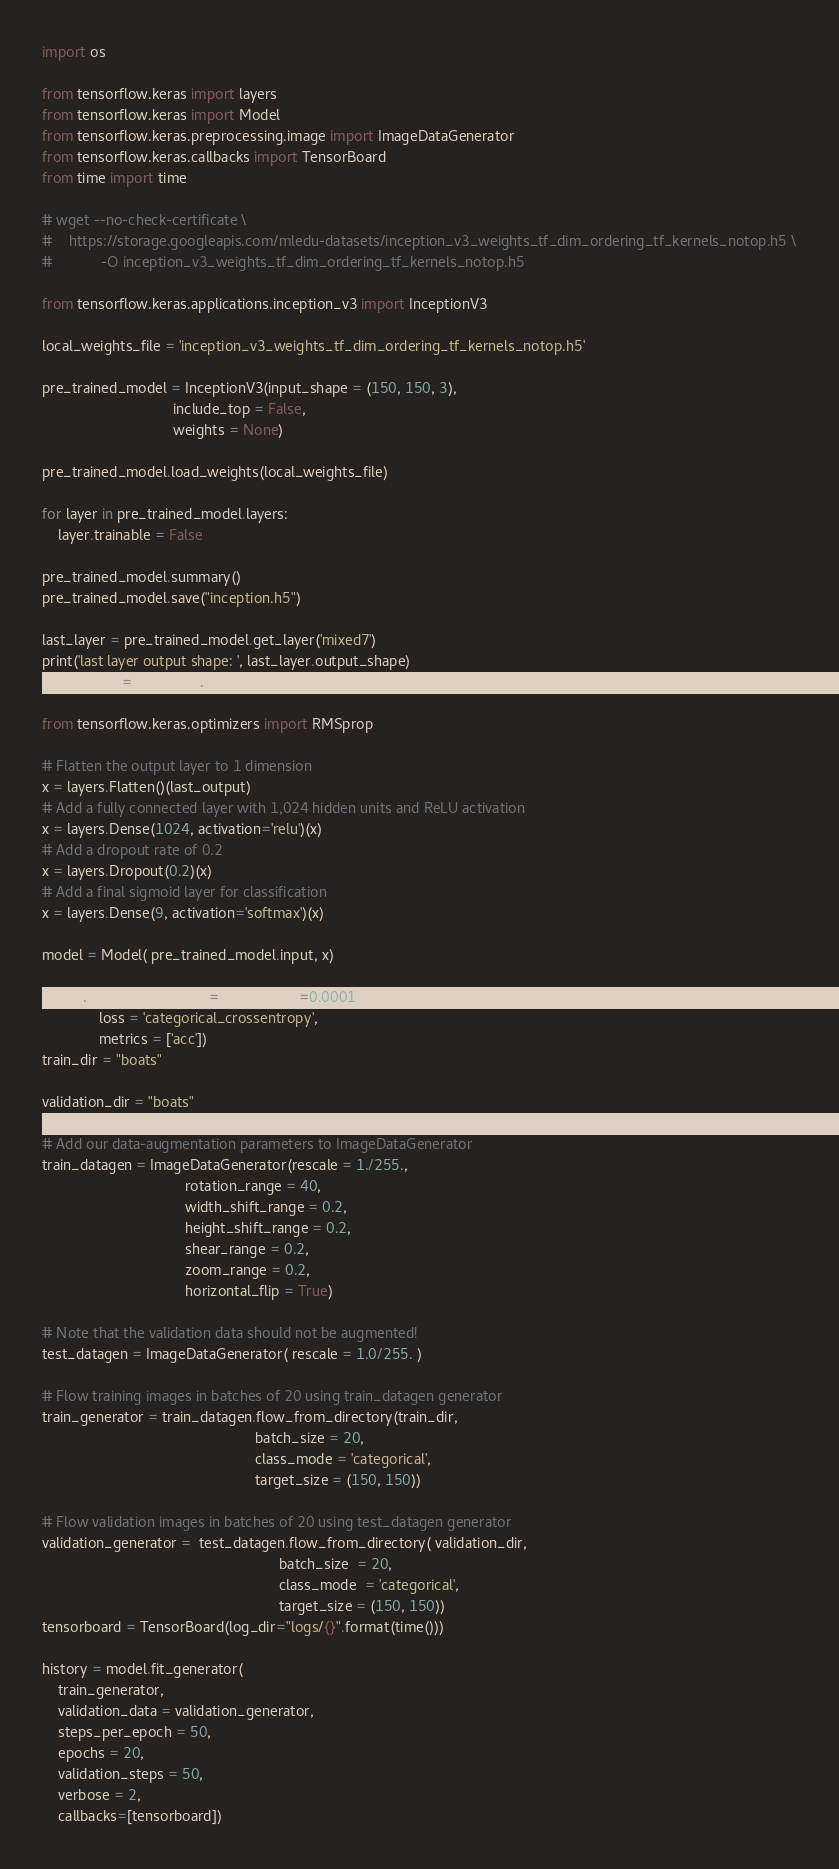Convert code to text. <code><loc_0><loc_0><loc_500><loc_500><_Python_>import os

from tensorflow.keras import layers
from tensorflow.keras import Model
from tensorflow.keras.preprocessing.image import ImageDataGenerator
from tensorflow.keras.callbacks import TensorBoard
from time import time

# wget --no-check-certificate \
#    https://storage.googleapis.com/mledu-datasets/inception_v3_weights_tf_dim_ordering_tf_kernels_notop.h5 \
#            -O inception_v3_weights_tf_dim_ordering_tf_kernels_notop.h5

from tensorflow.keras.applications.inception_v3 import InceptionV3

local_weights_file = 'inception_v3_weights_tf_dim_ordering_tf_kernels_notop.h5'

pre_trained_model = InceptionV3(input_shape = (150, 150, 3),
                                include_top = False,
                                weights = None)

pre_trained_model.load_weights(local_weights_file)

for layer in pre_trained_model.layers:
    layer.trainable = False

pre_trained_model.summary()
pre_trained_model.save("inception.h5")

last_layer = pre_trained_model.get_layer('mixed7')
print('last layer output shape: ', last_layer.output_shape)
last_output = last_layer.output

from tensorflow.keras.optimizers import RMSprop

# Flatten the output layer to 1 dimension
x = layers.Flatten()(last_output)
# Add a fully connected layer with 1,024 hidden units and ReLU activation
x = layers.Dense(1024, activation='relu')(x)
# Add a dropout rate of 0.2
x = layers.Dropout(0.2)(x)
# Add a final sigmoid layer for classification
x = layers.Dense(9, activation='softmax')(x)

model = Model( pre_trained_model.input, x)

model.compile(optimizer = RMSprop(lr=0.0001),
              loss = 'categorical_crossentropy',
              metrics = ['acc'])
train_dir = "boats"

validation_dir = "boats"

# Add our data-augmentation parameters to ImageDataGenerator
train_datagen = ImageDataGenerator(rescale = 1./255.,
                                   rotation_range = 40,
                                   width_shift_range = 0.2,
                                   height_shift_range = 0.2,
                                   shear_range = 0.2,
                                   zoom_range = 0.2,
                                   horizontal_flip = True)

# Note that the validation data should not be augmented!
test_datagen = ImageDataGenerator( rescale = 1.0/255. )

# Flow training images in batches of 20 using train_datagen generator
train_generator = train_datagen.flow_from_directory(train_dir,
                                                    batch_size = 20,
                                                    class_mode = 'categorical',
                                                    target_size = (150, 150))

# Flow validation images in batches of 20 using test_datagen generator
validation_generator =  test_datagen.flow_from_directory( validation_dir,
                                                          batch_size  = 20,
                                                          class_mode  = 'categorical',
                                                          target_size = (150, 150))
tensorboard = TensorBoard(log_dir="logs/{}".format(time()))

history = model.fit_generator(
    train_generator,
    validation_data = validation_generator,
    steps_per_epoch = 50,
    epochs = 20,
    validation_steps = 50,
    verbose = 2,
    callbacks=[tensorboard])</code> 